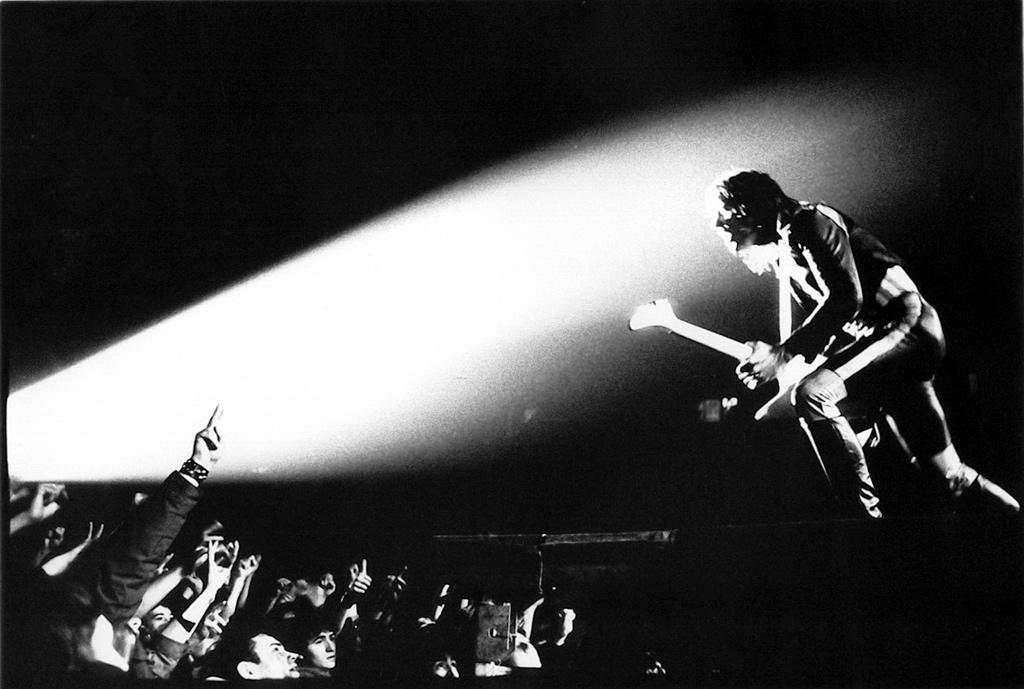What is the man on the stage doing? The man is playing a guitar and singing. Who is present in front of the stage? There are people standing in front of the stage. What is the man holding while performing? The man is holding a guitar. What can be found on the surface of the stage? There are objects on the surface of the stage. Where is the stove located in the image? There is no stove present in the image. What type of soap is being used by the man while singing? The man is not using soap in the image; he is playing a guitar and singing. 